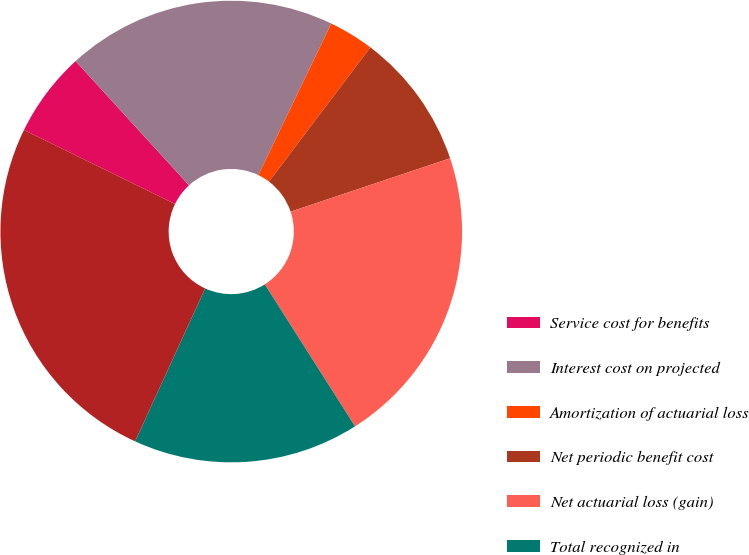Convert chart to OTSL. <chart><loc_0><loc_0><loc_500><loc_500><pie_chart><fcel>Service cost for benefits<fcel>Interest cost on projected<fcel>Amortization of actuarial loss<fcel>Net periodic benefit cost<fcel>Net actuarial loss (gain)<fcel>Total recognized in<fcel>Total recognized in net<nl><fcel>5.97%<fcel>18.91%<fcel>3.17%<fcel>9.56%<fcel>21.13%<fcel>15.85%<fcel>25.41%<nl></chart> 